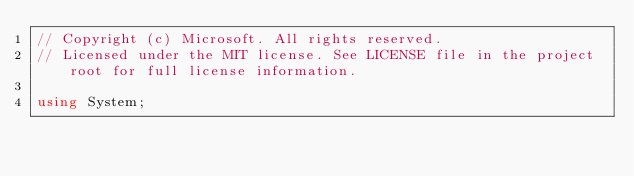<code> <loc_0><loc_0><loc_500><loc_500><_C#_>// Copyright (c) Microsoft. All rights reserved.
// Licensed under the MIT license. See LICENSE file in the project root for full license information.

using System;</code> 